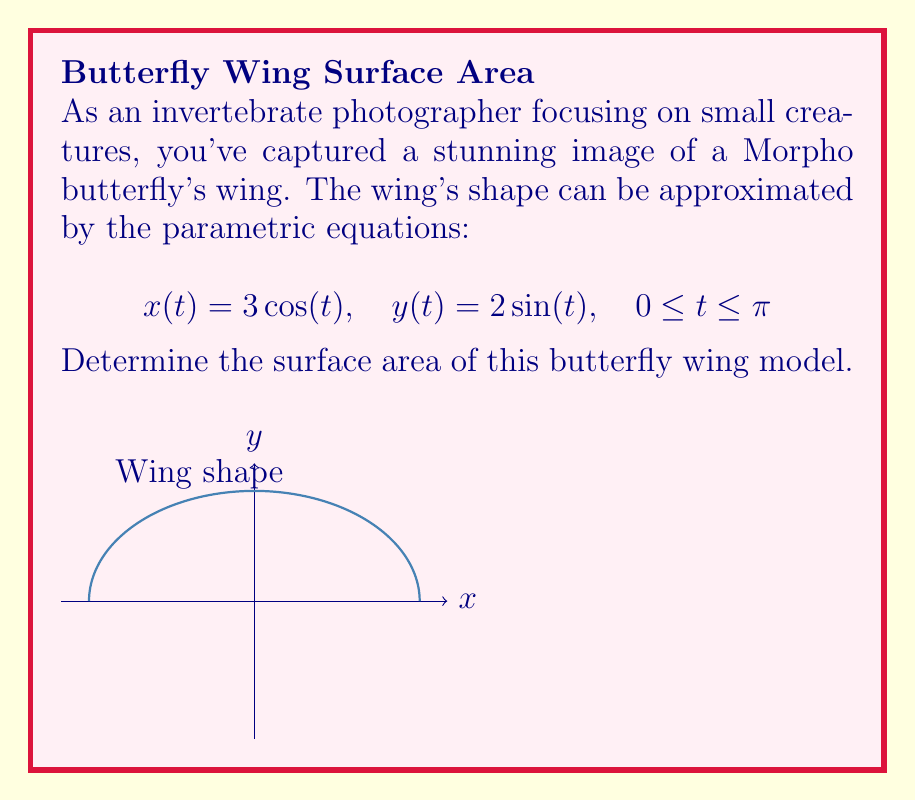Can you answer this question? To find the surface area using parametric equations, we'll use the formula:

$$\text{Area} = \int_{a}^{b} \sqrt{\left(\frac{dx}{dt}\right)^2 + \left(\frac{dy}{dt}\right)^2} dt$$

Step 1: Find $\frac{dx}{dt}$ and $\frac{dy}{dt}$
$$\frac{dx}{dt} = -3\sin(t)$$
$$\frac{dy}{dt} = 2\cos(t)$$

Step 2: Substitute into the formula
$$\text{Area} = \int_{0}^{\pi} \sqrt{(-3\sin(t))^2 + (2\cos(t))^2} dt$$

Step 3: Simplify under the square root
$$\text{Area} = \int_{0}^{\pi} \sqrt{9\sin^2(t) + 4\cos^2(t)} dt$$

Step 4: Factor out the common term
$$\text{Area} = \int_{0}^{\pi} \sqrt{4(\frac{9}{4}\sin^2(t) + \cos^2(t))} dt$$

Step 5: Use the identity $\sin^2(t) + \cos^2(t) = 1$
$$\text{Area} = \int_{0}^{\pi} \sqrt{4(\frac{9}{4}\sin^2(t) + \cos^2(t))} dt$$
$$= \int_{0}^{\pi} \sqrt{4(\frac{9}{4}\sin^2(t) + (1-\sin^2(t)))} dt$$
$$= \int_{0}^{\pi} \sqrt{4(\frac{9}{4}\sin^2(t) + 1-\sin^2(t))} dt$$
$$= \int_{0}^{\pi} \sqrt{4(\frac{5}{4}\sin^2(t) + 1)} dt$$
$$= \int_{0}^{\pi} 2\sqrt{\frac{5}{4}\sin^2(t) + 1} dt$$

Step 6: This integral doesn't have an elementary antiderivative. We need to use numerical integration or elliptic integrals. Using numerical integration, we get:

$$\text{Area} \approx 8.4823$$
Answer: $8.4823$ square units 